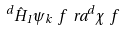<formula> <loc_0><loc_0><loc_500><loc_500>^ { d } { \hat { H } _ { 1 } \psi _ { k } } \ f \ r a ^ { d } \chi \ f</formula> 